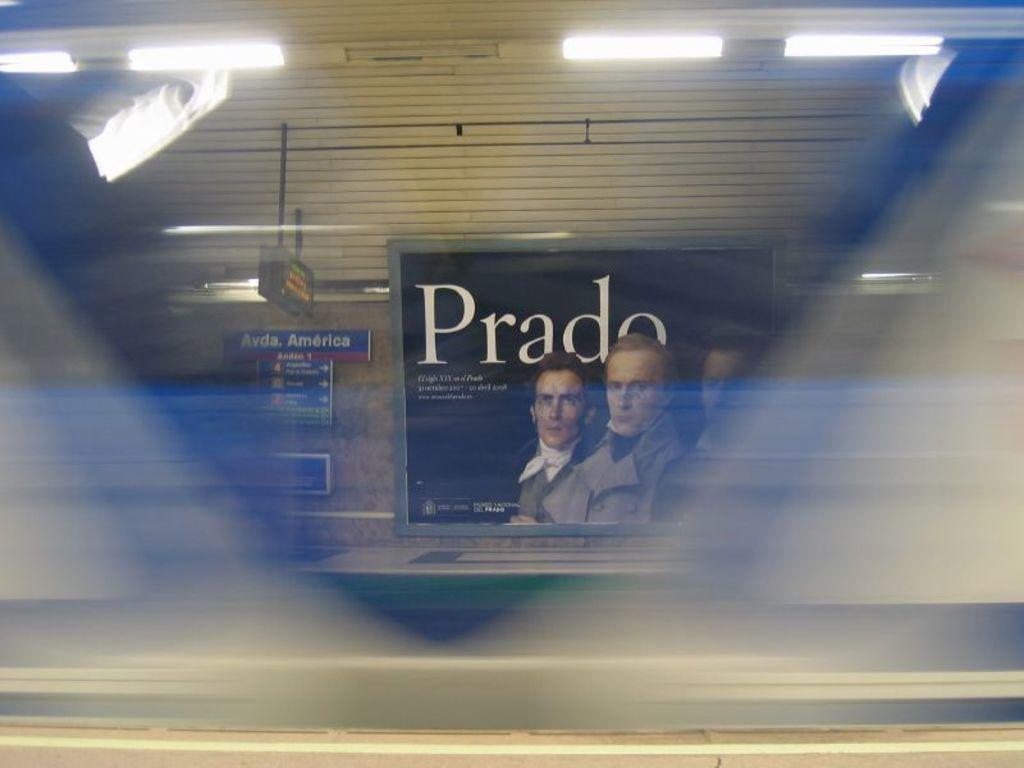In one or two sentences, can you explain what this image depicts? In this image, there is a board on the wall contains three persons and some text. There are lights in the top left and in the top right of the image. 